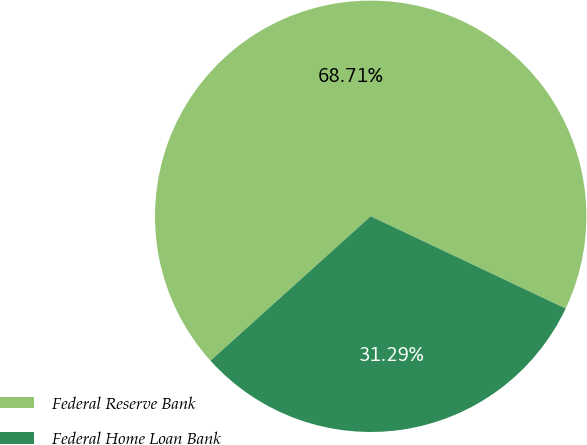Convert chart. <chart><loc_0><loc_0><loc_500><loc_500><pie_chart><fcel>Federal Reserve Bank<fcel>Federal Home Loan Bank<nl><fcel>68.71%<fcel>31.29%<nl></chart> 